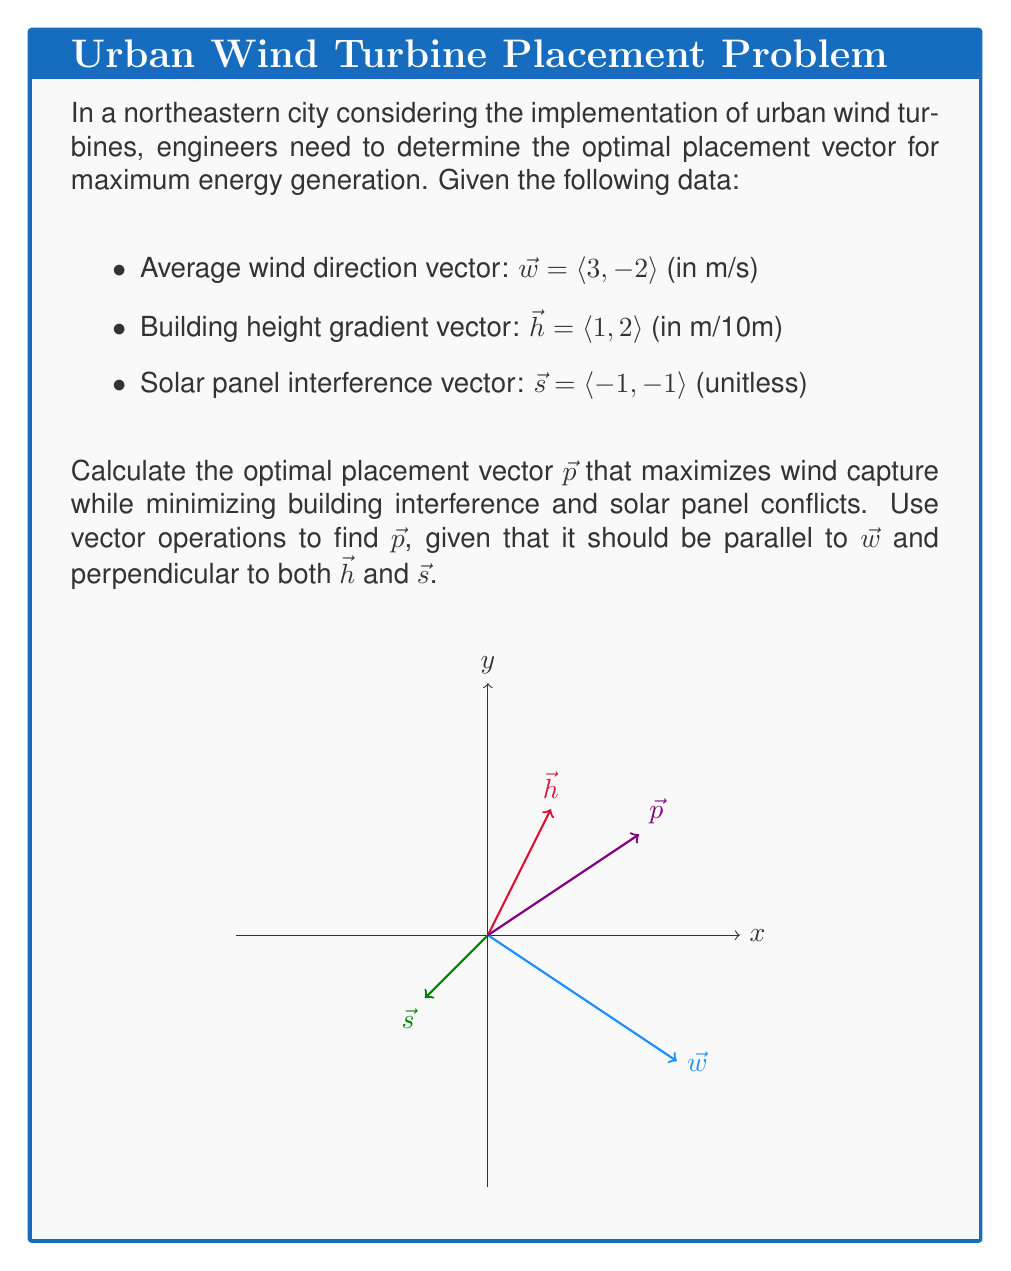Show me your answer to this math problem. To find the optimal placement vector $\vec{p}$, we'll follow these steps:

1) First, we need to find a vector perpendicular to both $\vec{h}$ and $\vec{s}$. We can do this using the cross product:

   $\vec{n} = \vec{h} \times \vec{s} = \langle 1, 2 \rangle \times \langle -1, -1 \rangle = 1(-1) - 2(-1) = -1 + 2 = 1$

   Note that in 2D, the cross product results in a scalar.

2) Now, we need to find a vector parallel to $\vec{w}$ and perpendicular to $\vec{n}$. We can do this by rotating $\vec{w}$ by 90° if necessary:

   $\vec{w}_{\perp} = \langle -2, -3 \rangle$

3) We check if $\vec{w}_{\perp}$ is perpendicular to $\vec{n}$ by calculating their dot product:

   $\vec{w}_{\perp} \cdot \vec{n} = (-2)(1) + (-3)(1) = -5 \neq 0$

   Since the dot product is not zero, $\vec{w}_{\perp}$ is not perpendicular to $\vec{n}$.

4) Therefore, $\vec{w}$ itself is perpendicular to $\vec{n}$, so our optimal placement vector $\vec{p}$ should be parallel to $\vec{w}$.

5) We normalize $\vec{w}$ to get a unit vector in the same direction:

   $\|\vec{w}\| = \sqrt{3^2 + (-2)^2} = \sqrt{13}$

   $\vec{p} = \frac{\vec{w}}{\|\vec{w}\|} = \left\langle \frac{3}{\sqrt{13}}, \frac{-2}{\sqrt{13}} \right\rangle$

This vector $\vec{p}$ is parallel to the wind direction, perpendicular to the building height gradient, and perpendicular to the solar panel interference vector, making it the optimal placement vector for wind turbines in this urban setting.
Answer: $\vec{p} = \left\langle \frac{3}{\sqrt{13}}, \frac{-2}{\sqrt{13}} \right\rangle$ 